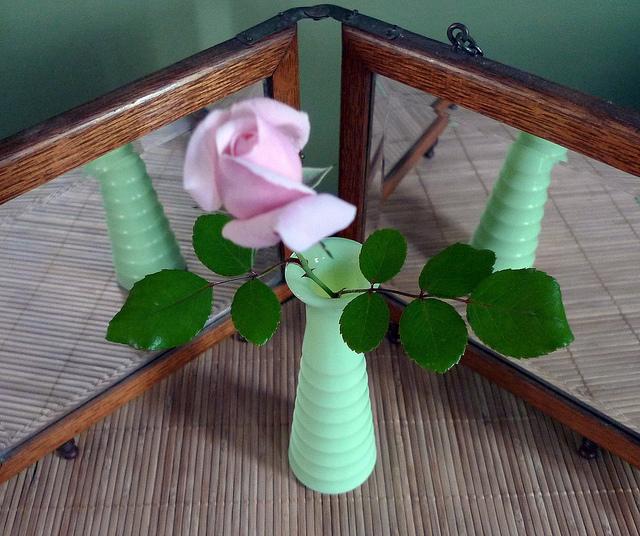How many mirrors are there?
Quick response, please. 2. What kind of flower is in the vase in this picture?
Be succinct. Rose. What color is the vase?
Answer briefly. Green. 